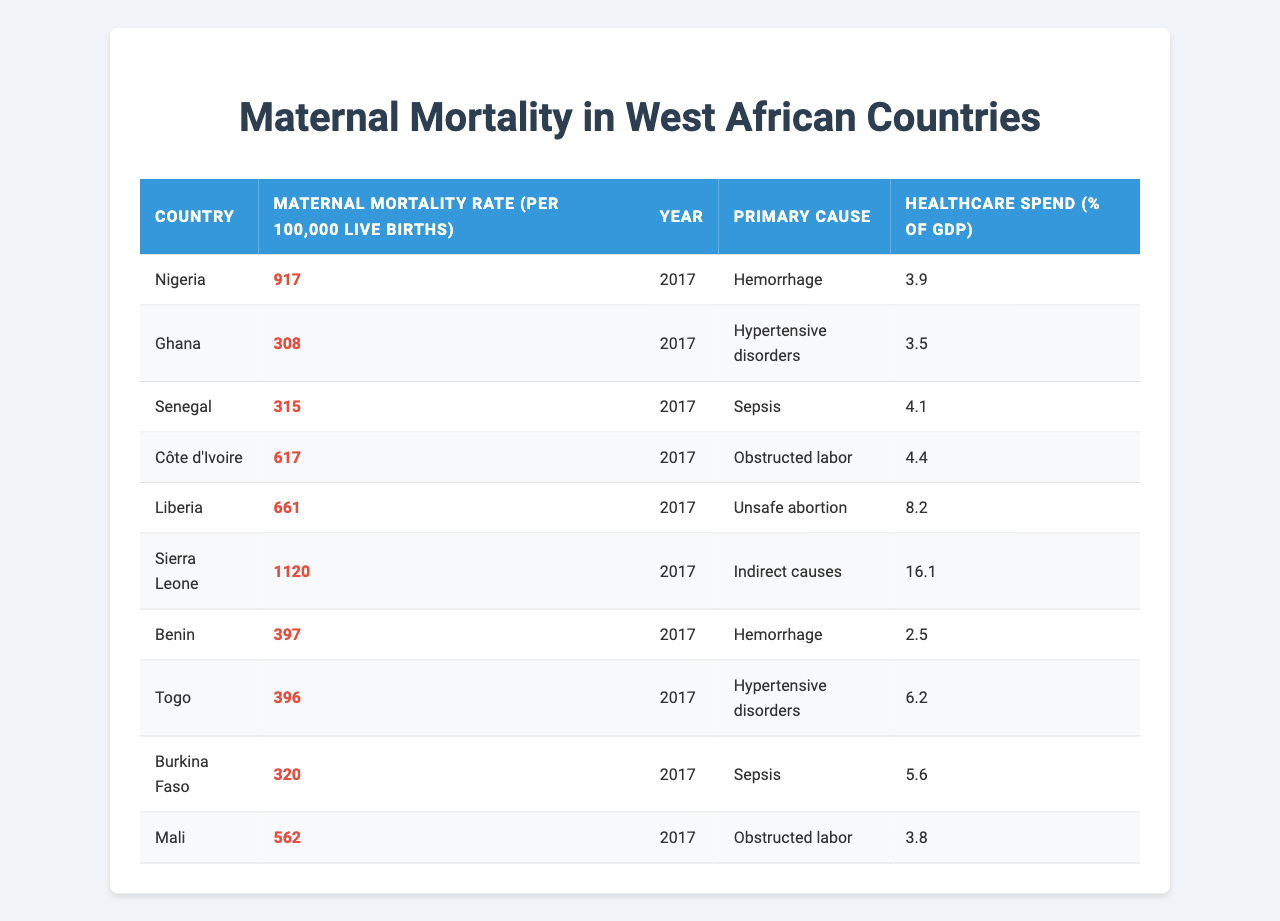What is the maternal mortality rate in Nigeria? The table lists Nigeria's maternal mortality rate as 917 per 100,000 live births in 2017.
Answer: 917 Which country has the highest maternal mortality rate? According to the table, Sierra Leone has the highest maternal mortality rate at 1120 per 100,000 live births in 2017.
Answer: Sierra Leone What is the primary cause of maternal mortality in Ghana? The table indicates that the primary cause of maternal mortality in Ghana is "Hypertensive disorders."
Answer: Hypertensive disorders Which country recorded the lowest healthcare spending as a percentage of GDP among the listed West African countries? By comparing the healthcare spending values, Benin has the lowest at 2.5%.
Answer: Benin What is the average maternal mortality rate for the countries listed in the table? To find the average, sum all the maternal mortality rates: 917 + 308 + 315 + 617 + 661 + 1120 + 397 + 396 + 320 + 562 = 5110. There are 10 countries, so the average is 5110 / 10 = 511.
Answer: 511 Is the primary cause of maternal mortality in Liberia unsafe abortion? The table shows that the primary cause in Liberia is "Unsafe abortion," so the answer is yes.
Answer: Yes Which country among the listed ones has a higher maternal mortality rate than the healthcare spending of 5% of GDP? In the table, only Sierra Leone (1120) and Liberia (661) have maternal mortality rates above 5% in GDP spending, as Sierra Leone has a spending of 16.1%. Therefore, both countries meet this condition.
Answer: Sierra Leone and Liberia If we consider the countries with a maternal mortality rate above 600, how many are there? From the table, the countries with a maternal mortality rate above 600 are Nigeria (917), Côte d'Ivoire (617), Liberia (661), and Sierra Leone (1120). This totals four countries.
Answer: 4 What type of maternal mortality is the primary cause in Mali? The table specifies that the primary cause of maternal mortality in Mali is "Obstructed labor."
Answer: Obstructed labor Which country has a maternal mortality rate closest to the average of all listed countries? The average was determined to be 511; the closest maternal mortality rate is Burkina Faso at 320, which is significantly below it. Thus, it can be argued that Togo at 396, though still below, is closest.
Answer: Togo 